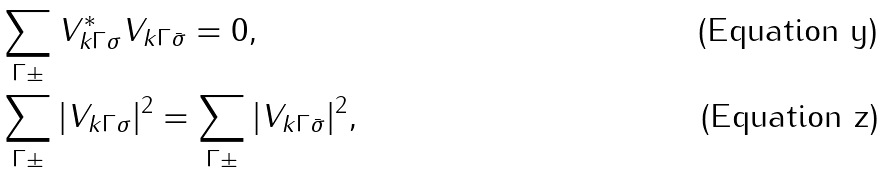<formula> <loc_0><loc_0><loc_500><loc_500>& \sum _ { \Gamma \pm } V _ { { k } \Gamma \sigma } ^ { * } V _ { { k } \Gamma \bar { \sigma } } = 0 , \\ & \sum _ { \Gamma \pm } | V _ { { k } \Gamma \sigma } | ^ { 2 } = \sum _ { \Gamma \pm } | V _ { { k } \Gamma \bar { \sigma } } | ^ { 2 } ,</formula> 